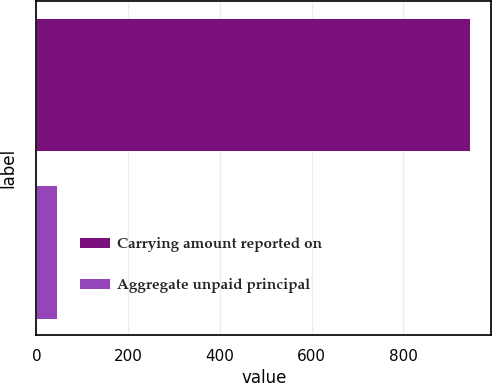<chart> <loc_0><loc_0><loc_500><loc_500><bar_chart><fcel>Carrying amount reported on<fcel>Aggregate unpaid principal<nl><fcel>945<fcel>44<nl></chart> 